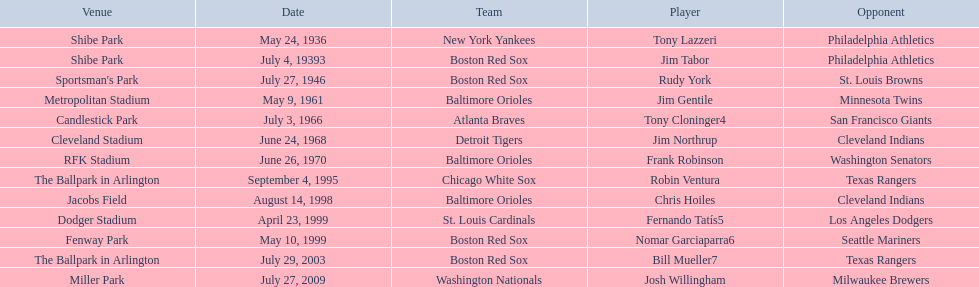Who were all of the players? Tony Lazzeri, Jim Tabor, Rudy York, Jim Gentile, Tony Cloninger4, Jim Northrup, Frank Robinson, Robin Ventura, Chris Hoiles, Fernando Tatís5, Nomar Garciaparra6, Bill Mueller7, Josh Willingham. Parse the table in full. {'header': ['Venue', 'Date', 'Team', 'Player', 'Opponent'], 'rows': [['Shibe Park', 'May 24, 1936', 'New York Yankees', 'Tony Lazzeri', 'Philadelphia Athletics'], ['Shibe Park', 'July 4, 19393', 'Boston Red Sox', 'Jim Tabor', 'Philadelphia Athletics'], ["Sportsman's Park", 'July 27, 1946', 'Boston Red Sox', 'Rudy York', 'St. Louis Browns'], ['Metropolitan Stadium', 'May 9, 1961', 'Baltimore Orioles', 'Jim Gentile', 'Minnesota Twins'], ['Candlestick Park', 'July 3, 1966', 'Atlanta Braves', 'Tony Cloninger4', 'San Francisco Giants'], ['Cleveland Stadium', 'June 24, 1968', 'Detroit Tigers', 'Jim Northrup', 'Cleveland Indians'], ['RFK Stadium', 'June 26, 1970', 'Baltimore Orioles', 'Frank Robinson', 'Washington Senators'], ['The Ballpark in Arlington', 'September 4, 1995', 'Chicago White Sox', 'Robin Ventura', 'Texas Rangers'], ['Jacobs Field', 'August 14, 1998', 'Baltimore Orioles', 'Chris Hoiles', 'Cleveland Indians'], ['Dodger Stadium', 'April 23, 1999', 'St. Louis Cardinals', 'Fernando Tatís5', 'Los Angeles Dodgers'], ['Fenway Park', 'May 10, 1999', 'Boston Red Sox', 'Nomar Garciaparra6', 'Seattle Mariners'], ['The Ballpark in Arlington', 'July 29, 2003', 'Boston Red Sox', 'Bill Mueller7', 'Texas Rangers'], ['Miller Park', 'July 27, 2009', 'Washington Nationals', 'Josh Willingham', 'Milwaukee Brewers']]} What year was there a player for the yankees? May 24, 1936. What was the name of that 1936 yankees player? Tony Lazzeri. 